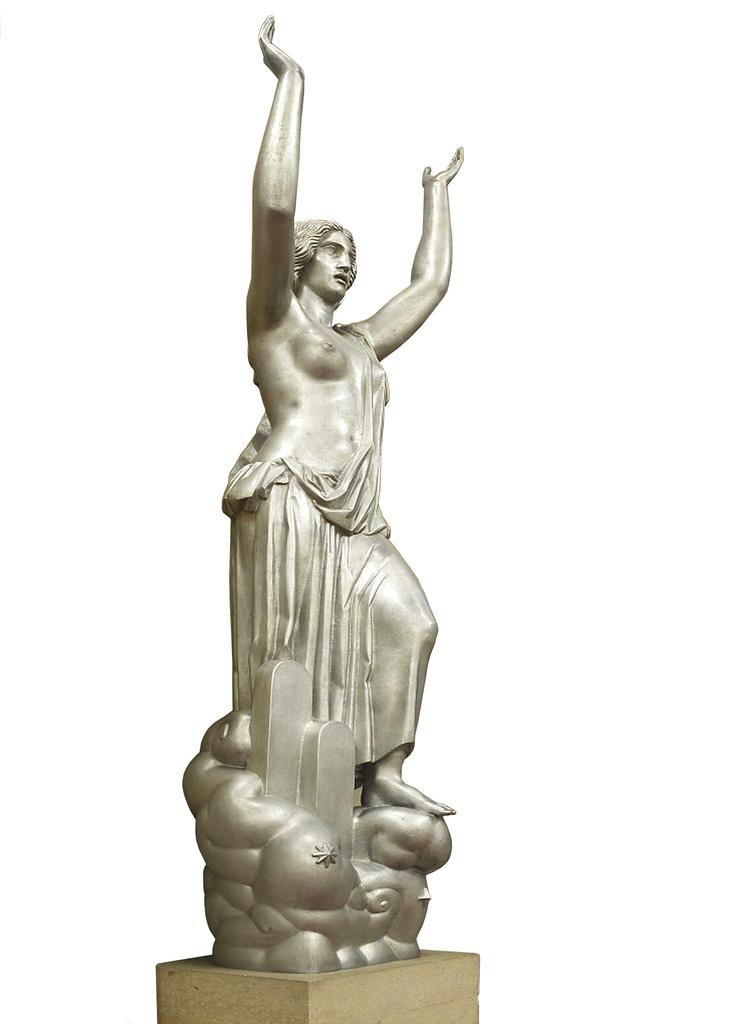What type of image is being described? The image appears to be animated. What can be seen in the animated image? There is a statue of a woman in the image. Where is the statue located? The statue is on a block. What type of swing can be seen near the statue in the image? There is no swing present in the image; it only features a statue of a woman on a block. 